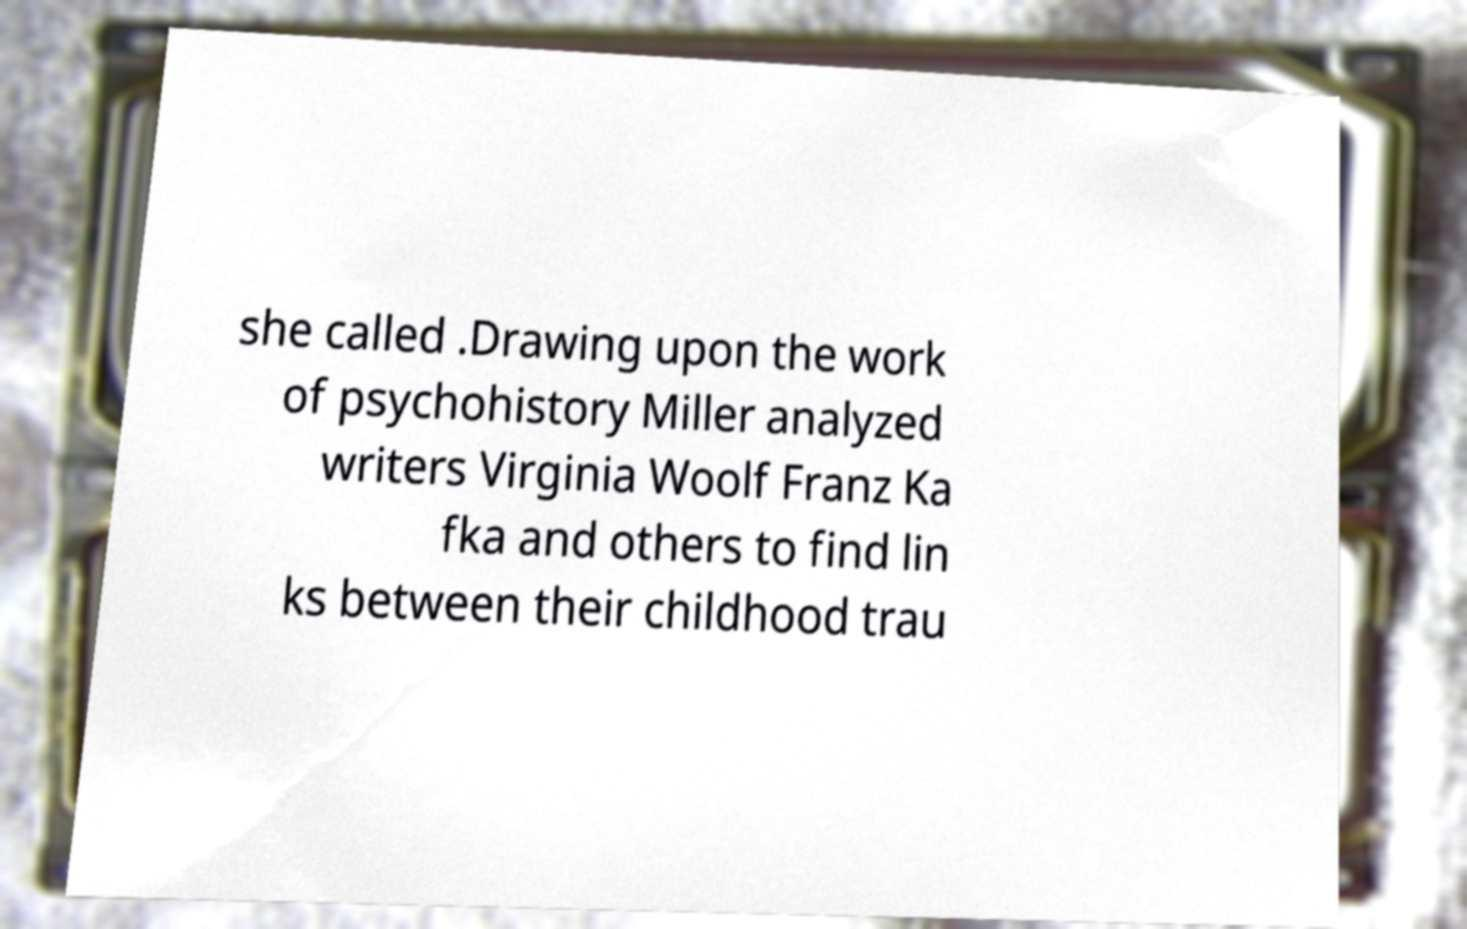There's text embedded in this image that I need extracted. Can you transcribe it verbatim? she called .Drawing upon the work of psychohistory Miller analyzed writers Virginia Woolf Franz Ka fka and others to find lin ks between their childhood trau 